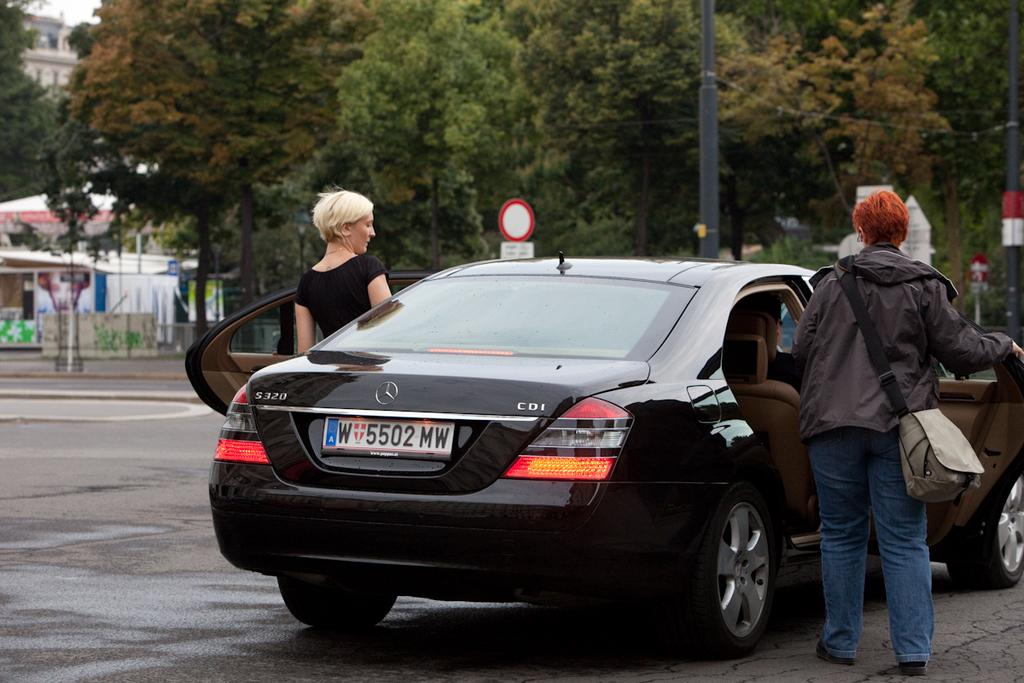How many people are in the image? There are two people in the image. What are the two people doing in the image? The two people are entering a car. What can be seen in the background of the image? There is a tree and a building visible in the image. What type of note is the image? There is no note present in the image. What kind of agreement do the two people have in the image? There is no indication of an agreement between the two people in the image. 